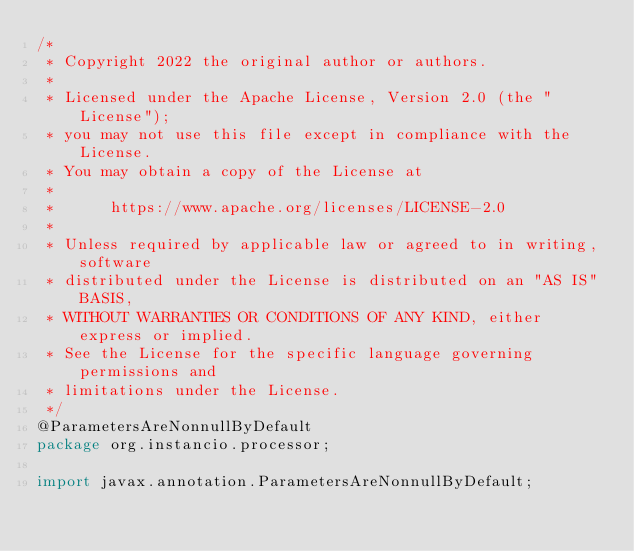<code> <loc_0><loc_0><loc_500><loc_500><_Java_>/*
 * Copyright 2022 the original author or authors.
 *
 * Licensed under the Apache License, Version 2.0 (the "License");
 * you may not use this file except in compliance with the License.
 * You may obtain a copy of the License at
 *
 *      https://www.apache.org/licenses/LICENSE-2.0
 *
 * Unless required by applicable law or agreed to in writing, software
 * distributed under the License is distributed on an "AS IS" BASIS,
 * WITHOUT WARRANTIES OR CONDITIONS OF ANY KIND, either express or implied.
 * See the License for the specific language governing permissions and
 * limitations under the License.
 */
@ParametersAreNonnullByDefault
package org.instancio.processor;

import javax.annotation.ParametersAreNonnullByDefault;</code> 